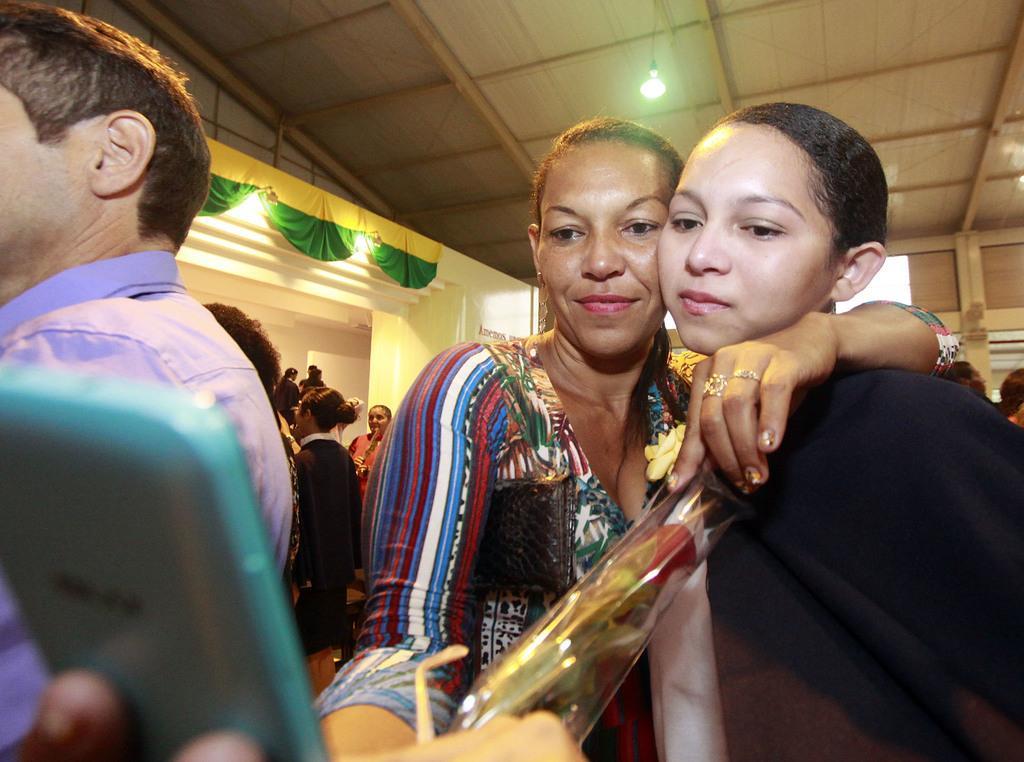Describe this image in one or two sentences. In this picture there is a woman standing and holding a mobile in one of her hand and a woman in her another hand and there are few other persons in the background. 